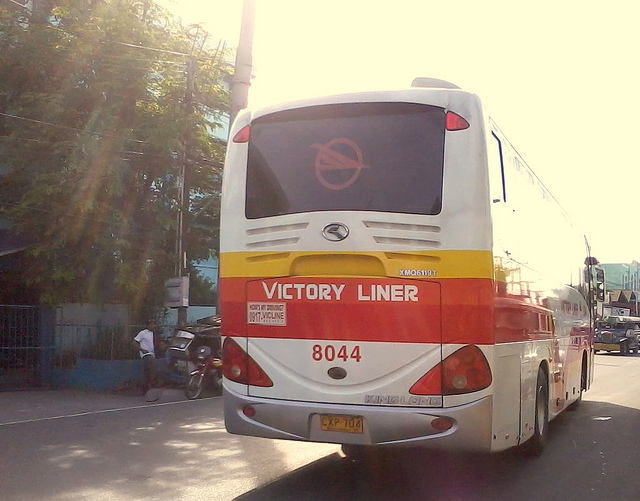<image>What color are the cars next to the bus? I am not sure. The cars next to the bus can be black, blue, or red. What color are the cars next to the bus? It is ambiguous what color the cars next to the bus are. 